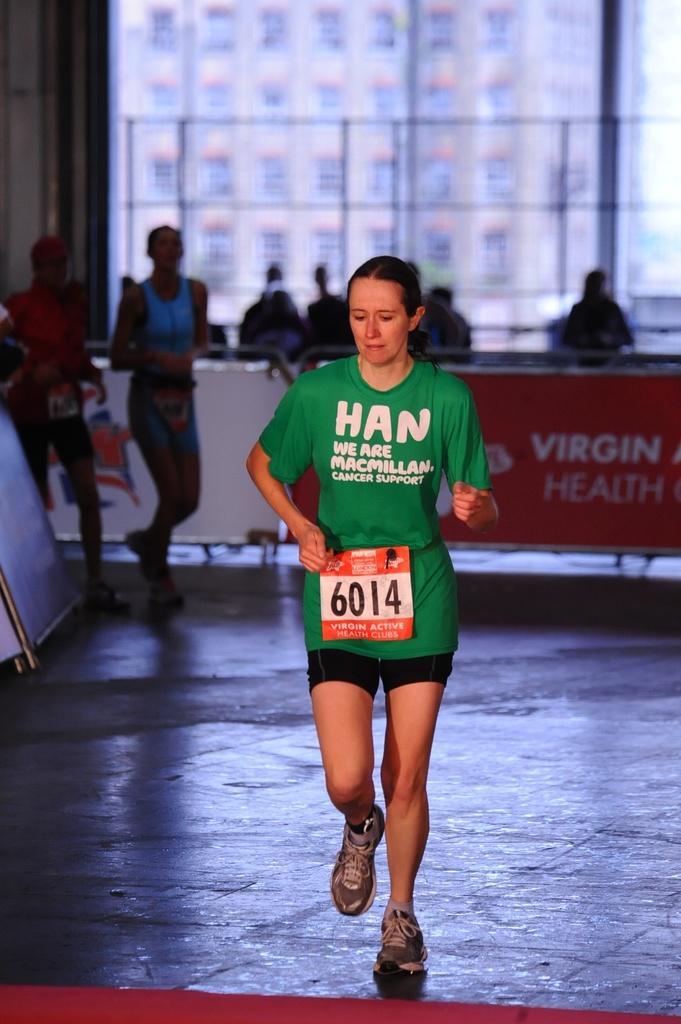Could you give a brief overview of what you see in this image? This image is taken outdoors. At the bottom of the image there is a floor. In the middle of the image a woman is running on the floor. On the left side of the image two men are running on the floor and there is a board. In the background there are a few people standing on the floor and there is a board with text on it. There is a window and through we can see a building. 